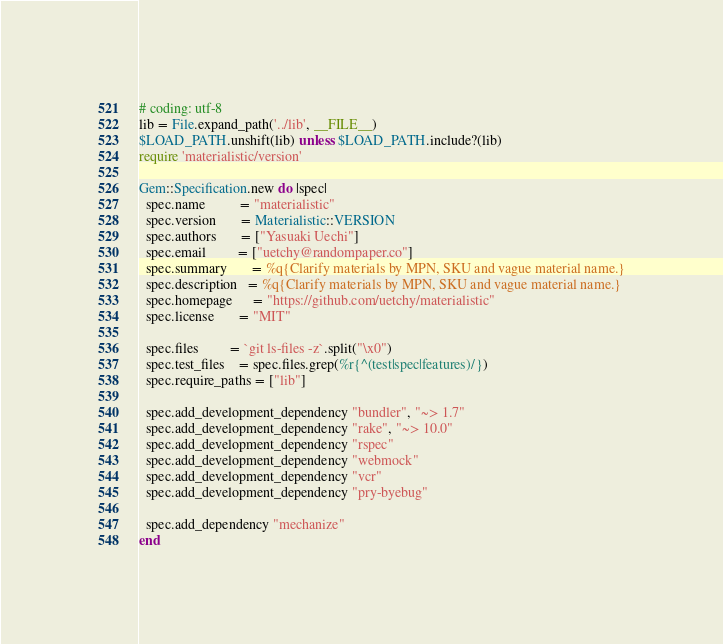Convert code to text. <code><loc_0><loc_0><loc_500><loc_500><_Ruby_># coding: utf-8
lib = File.expand_path('../lib', __FILE__)
$LOAD_PATH.unshift(lib) unless $LOAD_PATH.include?(lib)
require 'materialistic/version'

Gem::Specification.new do |spec|
  spec.name          = "materialistic"
  spec.version       = Materialistic::VERSION
  spec.authors       = ["Yasuaki Uechi"]
  spec.email         = ["uetchy@randompaper.co"]
  spec.summary       = %q{Clarify materials by MPN, SKU and vague material name.}
  spec.description   = %q{Clarify materials by MPN, SKU and vague material name.}
  spec.homepage      = "https://github.com/uetchy/materialistic"
  spec.license       = "MIT"

  spec.files         = `git ls-files -z`.split("\x0")
  spec.test_files    = spec.files.grep(%r{^(test|spec|features)/})
  spec.require_paths = ["lib"]

  spec.add_development_dependency "bundler", "~> 1.7"
  spec.add_development_dependency "rake", "~> 10.0"
  spec.add_development_dependency "rspec"
  spec.add_development_dependency "webmock"
  spec.add_development_dependency "vcr"
  spec.add_development_dependency "pry-byebug"

  spec.add_dependency "mechanize"
end
</code> 